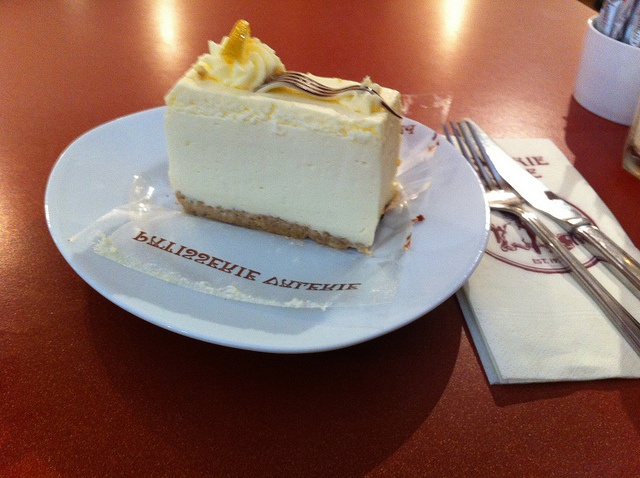Describe the objects in this image and their specific colors. I can see dining table in brown, maroon, black, and salmon tones, cake in brown, darkgray, and tan tones, fork in brown, gray, darkgray, and lightgray tones, bowl in brown, darkgray, and gray tones, and knife in brown, white, darkgray, and gray tones in this image. 